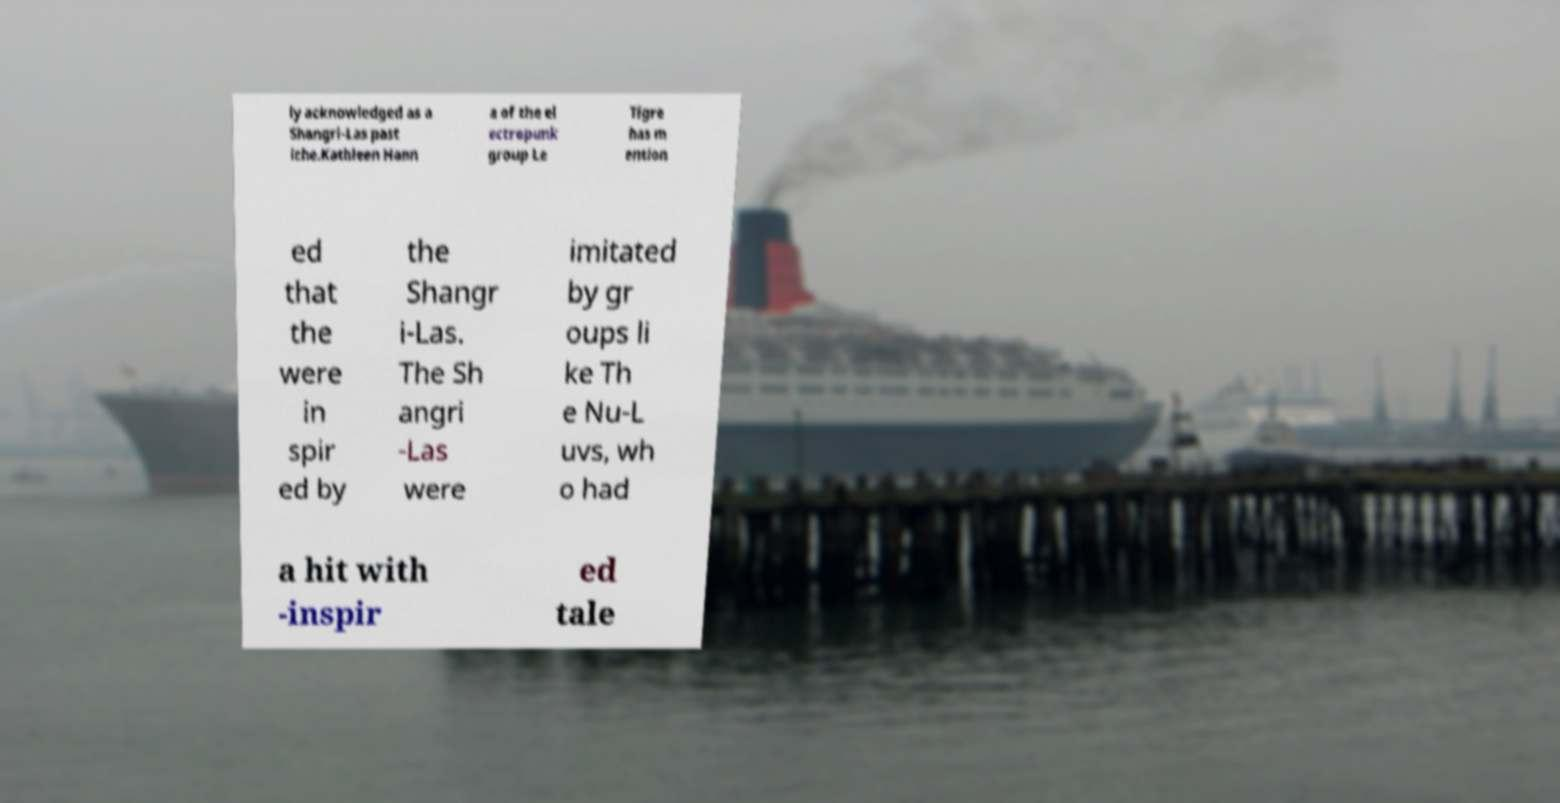Can you read and provide the text displayed in the image?This photo seems to have some interesting text. Can you extract and type it out for me? ly acknowledged as a Shangri-Las past iche.Kathleen Hann a of the el ectropunk group Le Tigre has m ention ed that the were in spir ed by the Shangr i-Las. The Sh angri -Las were imitated by gr oups li ke Th e Nu-L uvs, wh o had a hit with -inspir ed tale 